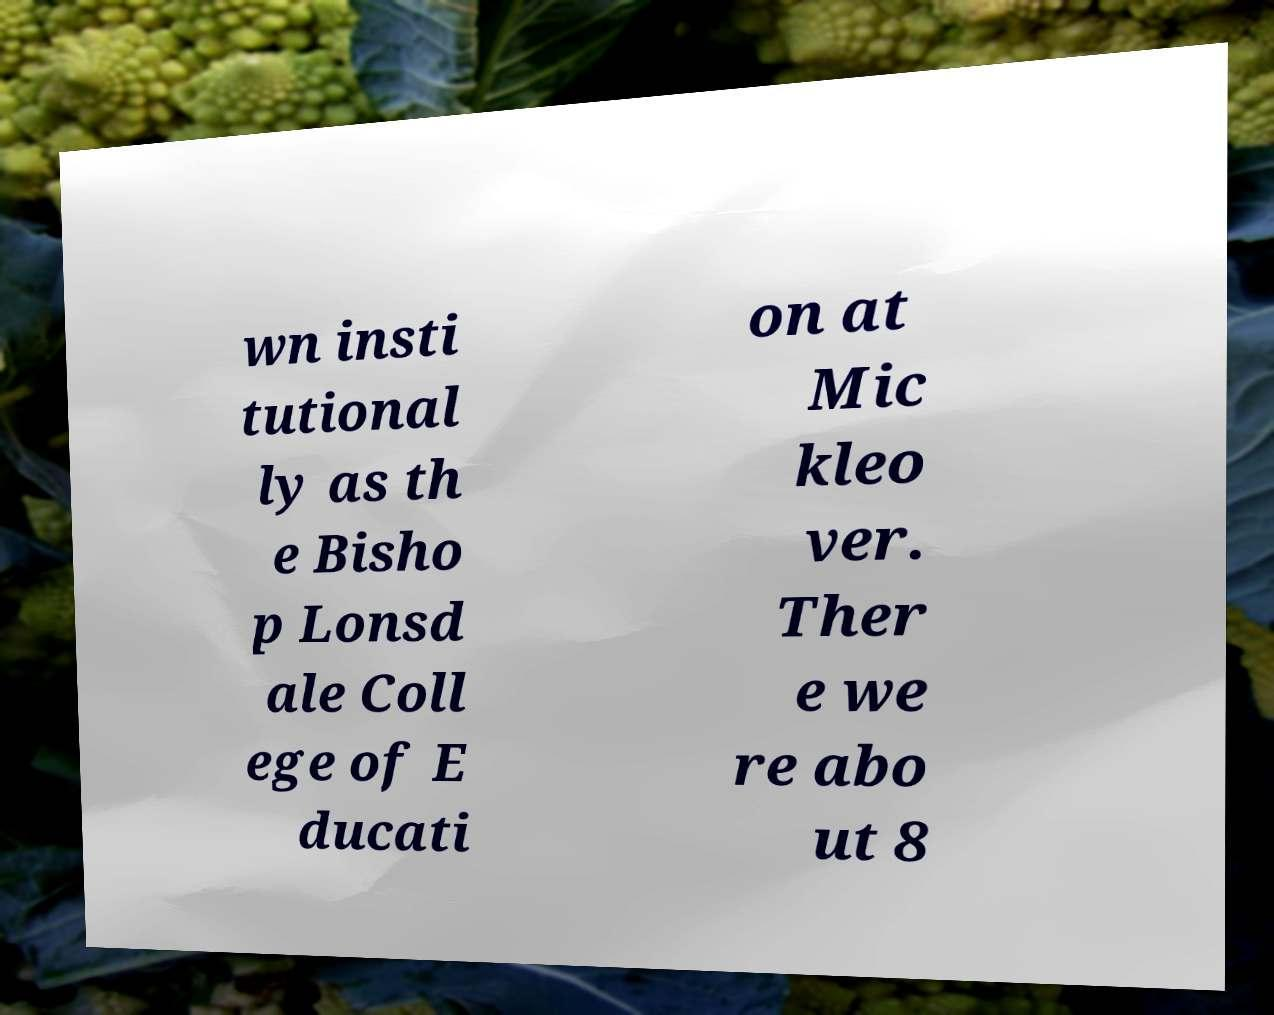Could you extract and type out the text from this image? wn insti tutional ly as th e Bisho p Lonsd ale Coll ege of E ducati on at Mic kleo ver. Ther e we re abo ut 8 